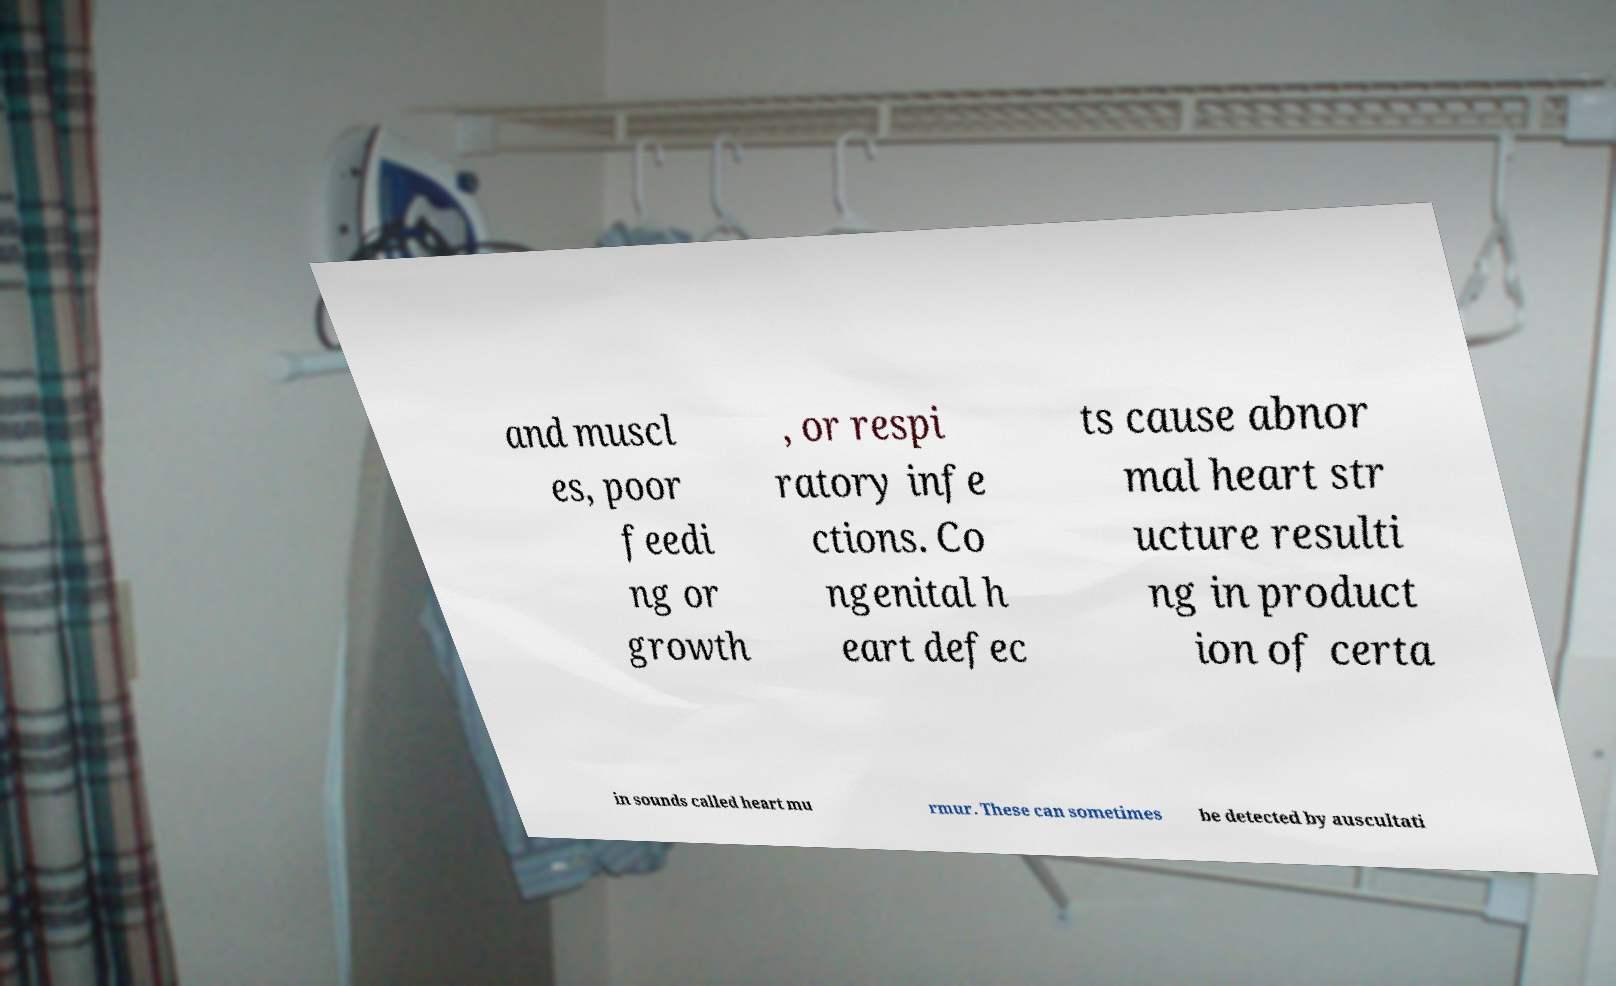Could you extract and type out the text from this image? and muscl es, poor feedi ng or growth , or respi ratory infe ctions. Co ngenital h eart defec ts cause abnor mal heart str ucture resulti ng in product ion of certa in sounds called heart mu rmur. These can sometimes be detected by auscultati 